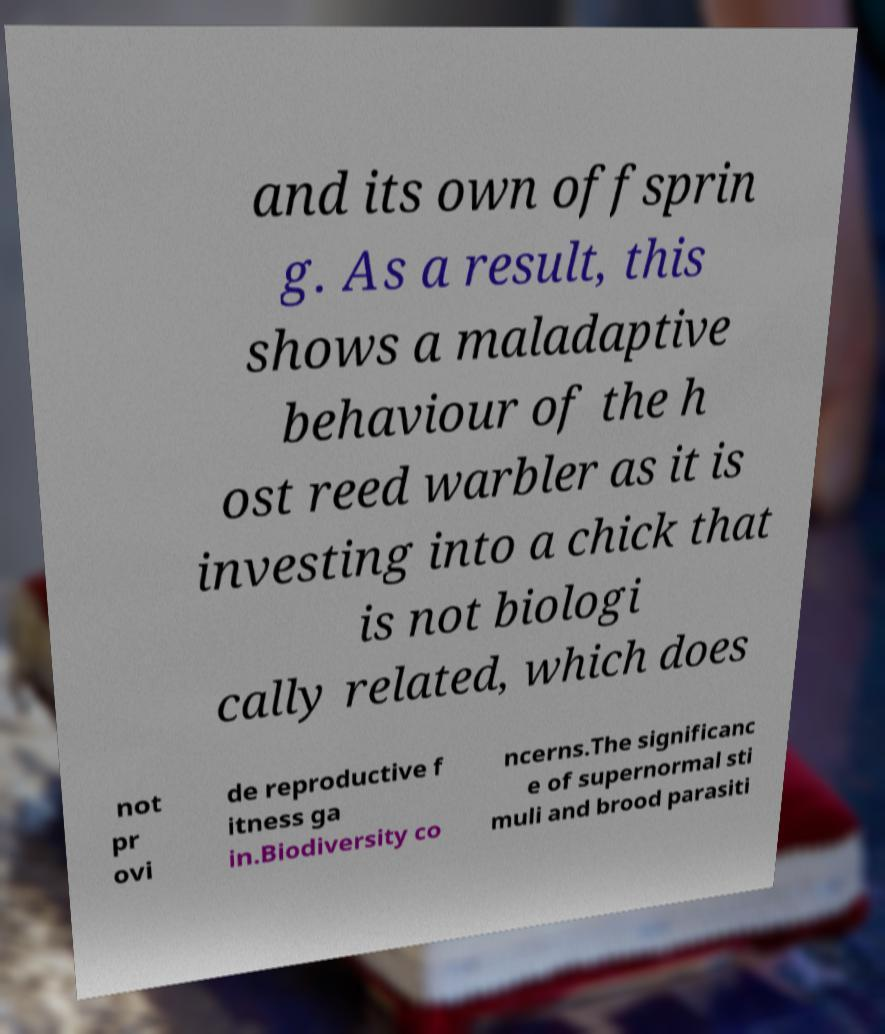Can you accurately transcribe the text from the provided image for me? and its own offsprin g. As a result, this shows a maladaptive behaviour of the h ost reed warbler as it is investing into a chick that is not biologi cally related, which does not pr ovi de reproductive f itness ga in.Biodiversity co ncerns.The significanc e of supernormal sti muli and brood parasiti 